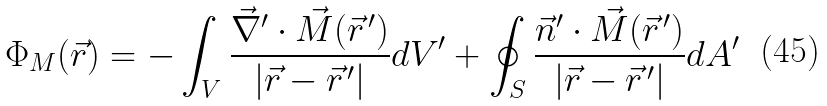<formula> <loc_0><loc_0><loc_500><loc_500>\Phi _ { M } ( \vec { r } ) = - \int _ { V } \frac { \vec { \nabla } ^ { \prime } \cdot \vec { M } ( \vec { r } ^ { \, \prime } ) } { | \vec { r } - \vec { r } ^ { \, \prime } | } d V ^ { \prime } + \oint _ { S } \frac { \vec { n } ^ { \prime } \cdot \vec { M } ( \vec { r } ^ { \, \prime } ) } { | \vec { r } - \vec { r } ^ { \, \prime } | } d A ^ { \prime }</formula> 